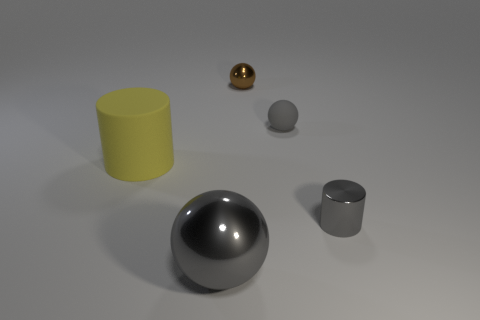Add 1 small rubber balls. How many objects exist? 6 Subtract all spheres. How many objects are left? 2 Add 4 tiny objects. How many tiny objects are left? 7 Add 3 balls. How many balls exist? 6 Subtract 0 gray cubes. How many objects are left? 5 Subtract all red metallic cylinders. Subtract all large things. How many objects are left? 3 